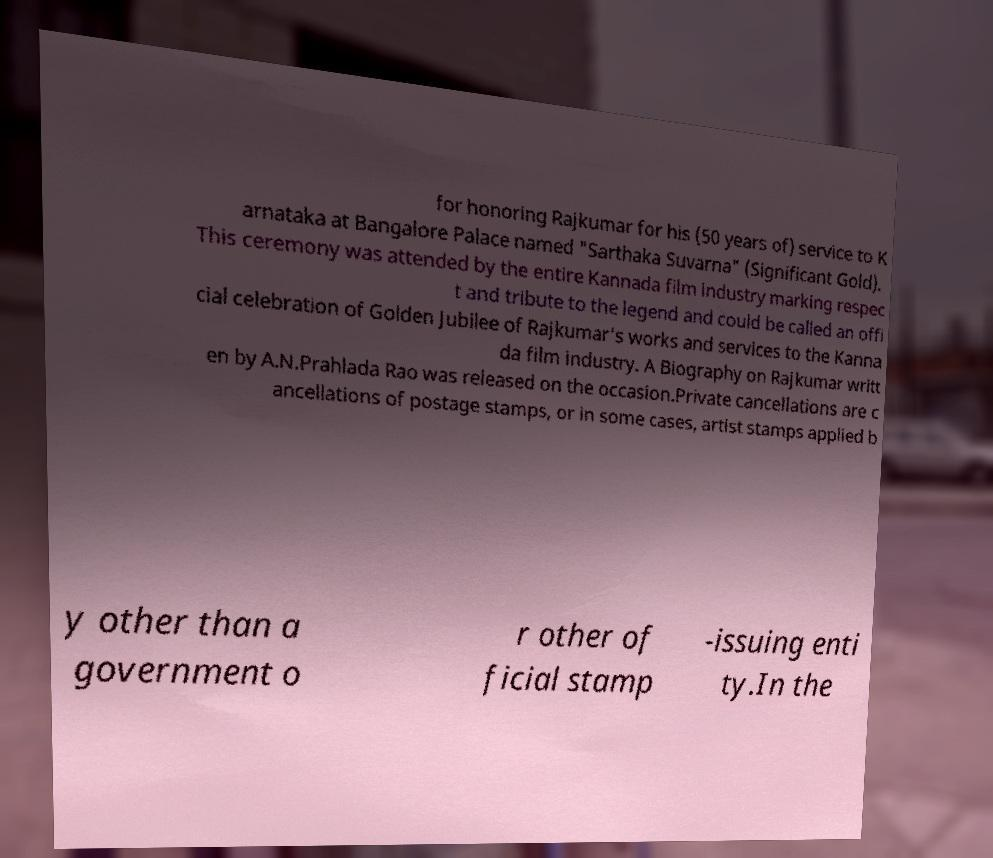Please read and relay the text visible in this image. What does it say? for honoring Rajkumar for his (50 years of) service to K arnataka at Bangalore Palace named "Sarthaka Suvarna" (Significant Gold). This ceremony was attended by the entire Kannada film industry marking respec t and tribute to the legend and could be called an offi cial celebration of Golden Jubilee of Rajkumar's works and services to the Kanna da film industry. A Biography on Rajkumar writt en by A.N.Prahlada Rao was released on the occasion.Private cancellations are c ancellations of postage stamps, or in some cases, artist stamps applied b y other than a government o r other of ficial stamp -issuing enti ty.In the 